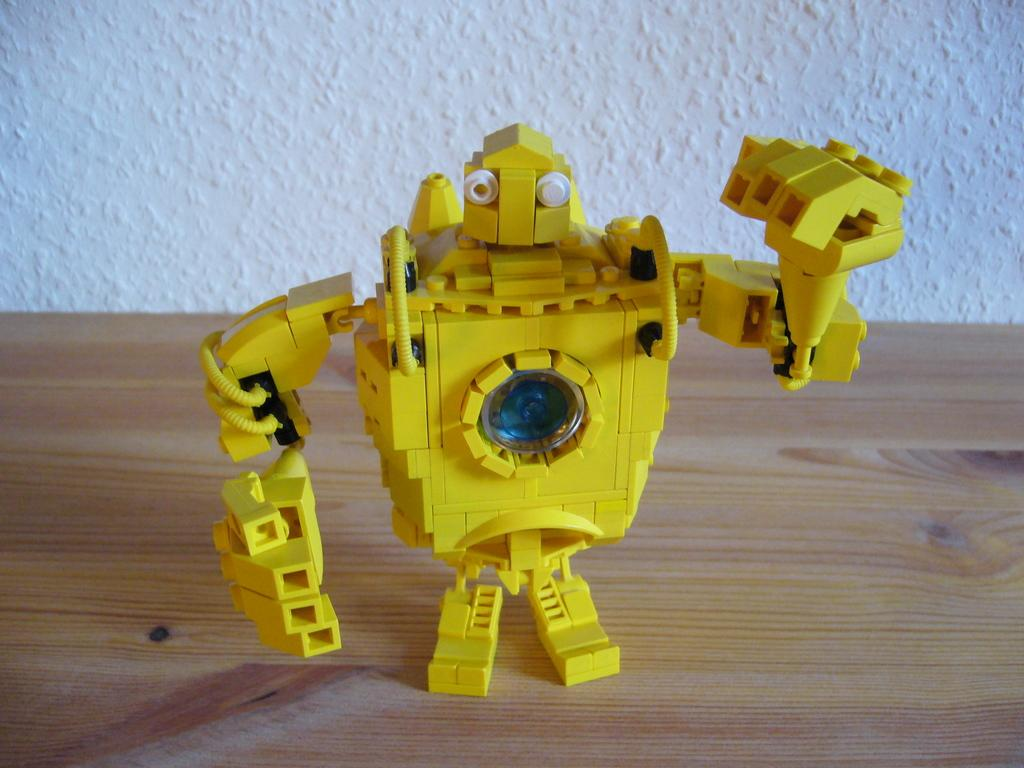Where was the image taken? The image was taken indoors. What can be seen in the background of the image? There is a wall in the background of the image. What is at the bottom of the image? There is a table at the bottom of the image. What is the main subject of the image? The main subject of the image is a toy robot, which is located in the middle of the image, on the table. What type of street is visible in the image? There is no street visible in the image; it was taken indoors. 